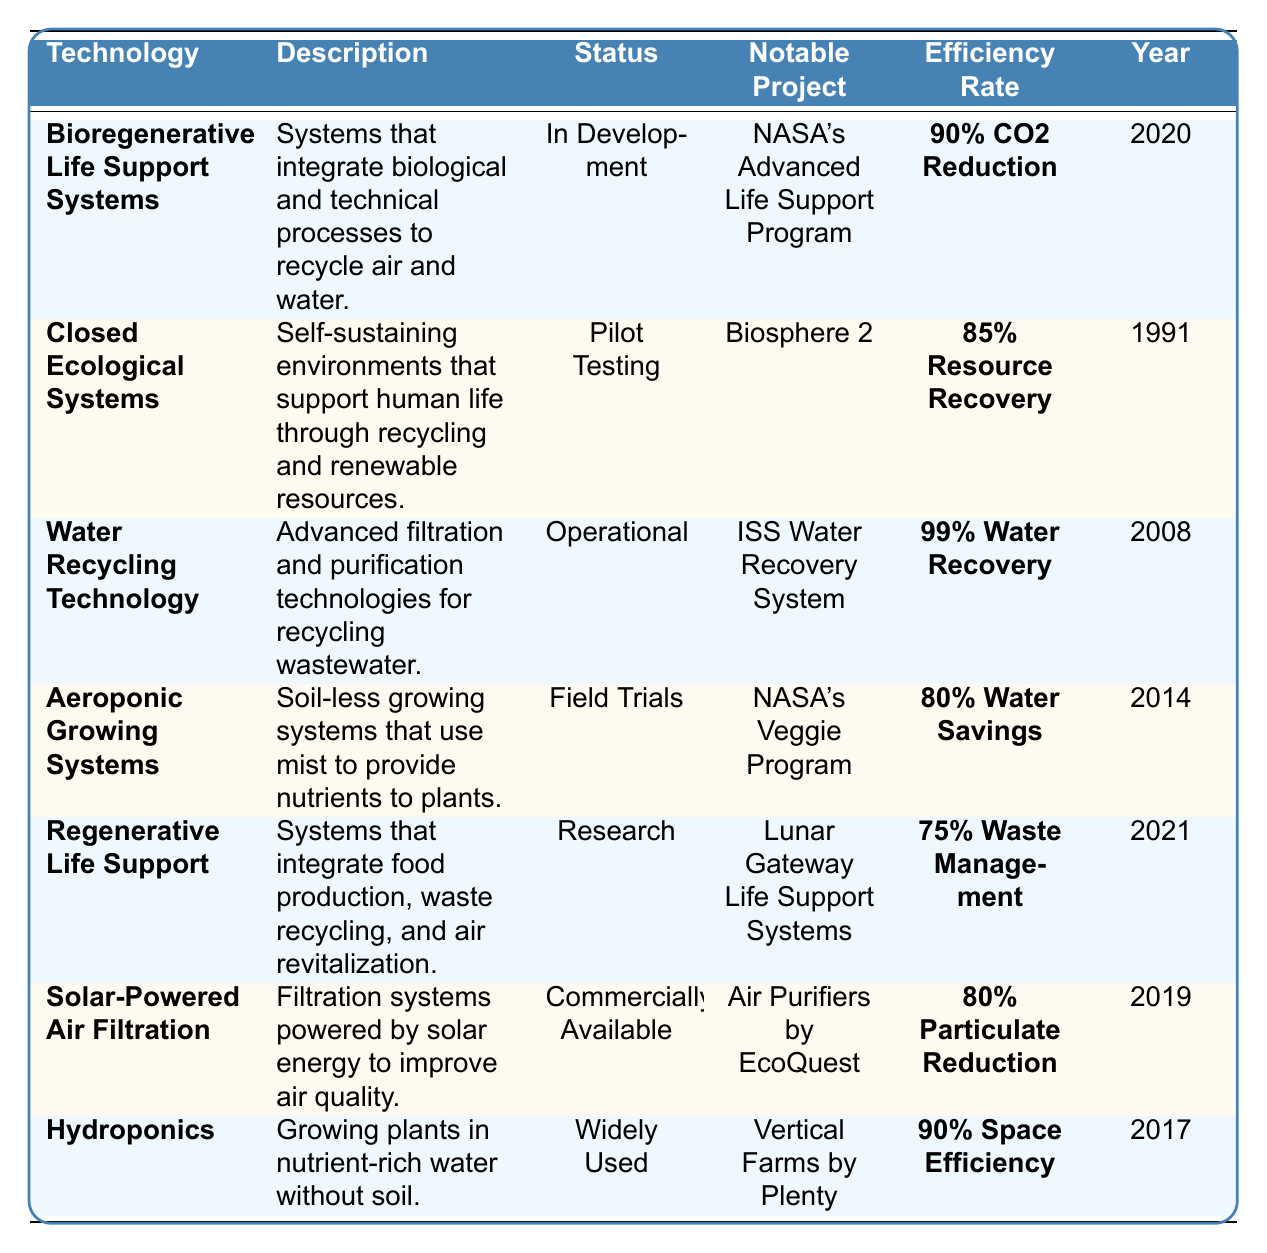What is the efficiency rate of Water Recycling Technology? The efficiency rate of Water Recycling Technology is listed in the table under the "Efficiency Rate" column for that technology. It is reported as 99% Water Recovery.
Answer: 99% Water Recovery Which technology has the highest efficiency rate? By comparing the efficiency rates listed in the table, Water Recycling Technology has the highest efficiency rate at 99% Water Recovery.
Answer: Water Recycling Technology Is Aeroponic Growing Systems currently operational? The status of Aeroponic Growing Systems is provided in the table, which indicates that it is in Field Trials, not operational.
Answer: No What year was Closed Ecological Systems introduced? The table specifies that Closed Ecological Systems was introduced in the year 1991.
Answer: 1991 Which technologies have a status of either "Pilot Testing" or "In Development"? To answer this, I will review the status column for these specific statuses. Bioregenerative Life Support Systems is "In Development," and Closed Ecological Systems is "Pilot Testing."
Answer: Bioregenerative Life Support Systems, Closed Ecological Systems What is the difference in efficiency rates between Bioregenerative Life Support Systems and Regenerative Life Support? I need to find the efficiency rates for both technologies in the table. Bioregenerative Life Support Systems has 90% CO2 Reduction, and Regenerative Life Support has 75% Waste Management. The difference is 90 - 75 = 15.
Answer: 15 Which system focuses on integrating food production and waste recycling? The table indicates that Regenerative Life Support is the system that integrates food production, waste recycling, and air revitalization.
Answer: Regenerative Life Support Are there any technologies that were introduced after 2010? I can examine the year introduced column and find that Water Recycling Technology (2008), Aeroponic Growing Systems (2014), Solar-Powered Air Filtration (2019), and Hydroponics (2017) all have their introduction years. The ones needed are Aeroponic Growing Systems, Solar-Powered Air Filtration, and Hydroponics.
Answer: Aeroponic Growing Systems, Solar-Powered Air Filtration, Hydroponics What is the average efficiency rate of the technologies that are commercially available? The table indicates that only Solar-Powered Air Filtration is commercially available with an efficiency rate of 80% Particulate Reduction. Therefore, the average efficiency rate is just 80% since there is only one data point.
Answer: 80% Which technology mentioned has the earliest notability project? By examining the "Notable Project" column for dates, it shows that the earliest project listed is "Biosphere 2" under Closed Ecological Systems, which was conducted in 1991.
Answer: Closed Ecological Systems What is the summary of the efficiency rates for the technologies categorized as "Research"? In the table, only Regenerative Life Support falls under "Research" with an efficiency rate of 75% Waste Management. Thus, the summary of efficiency rates for those technologies is simply 75%.
Answer: 75% 